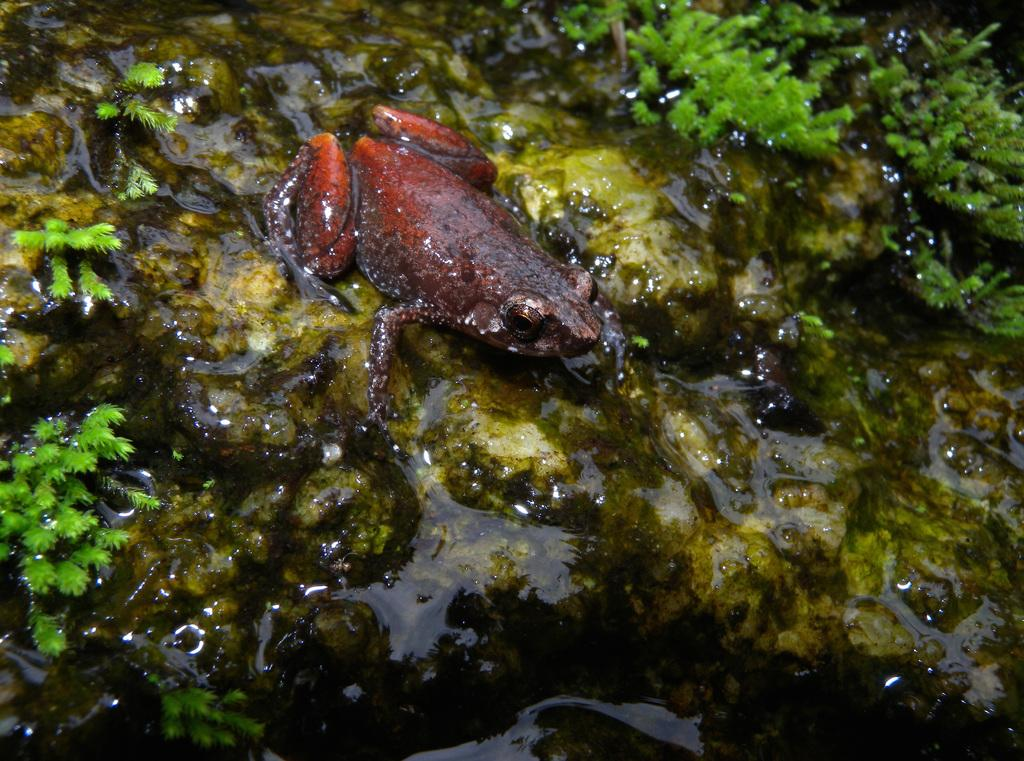What is the primary element in the image? There is water in the image. What type of living organisms can be seen in the image? There are tiny plants and a frog in the image. What other objects are visible in the image? Stones are visible in the image. What type of gold ornament is hanging from the frog's mouth in the image? There is no gold ornament present in the image, and the frog is not depicted as holding anything in its mouth. 